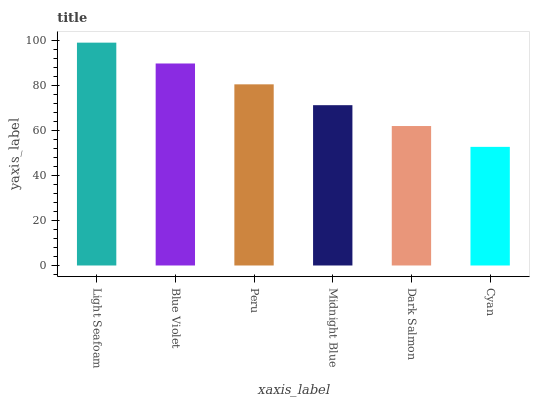Is Blue Violet the minimum?
Answer yes or no. No. Is Blue Violet the maximum?
Answer yes or no. No. Is Light Seafoam greater than Blue Violet?
Answer yes or no. Yes. Is Blue Violet less than Light Seafoam?
Answer yes or no. Yes. Is Blue Violet greater than Light Seafoam?
Answer yes or no. No. Is Light Seafoam less than Blue Violet?
Answer yes or no. No. Is Peru the high median?
Answer yes or no. Yes. Is Midnight Blue the low median?
Answer yes or no. Yes. Is Cyan the high median?
Answer yes or no. No. Is Blue Violet the low median?
Answer yes or no. No. 